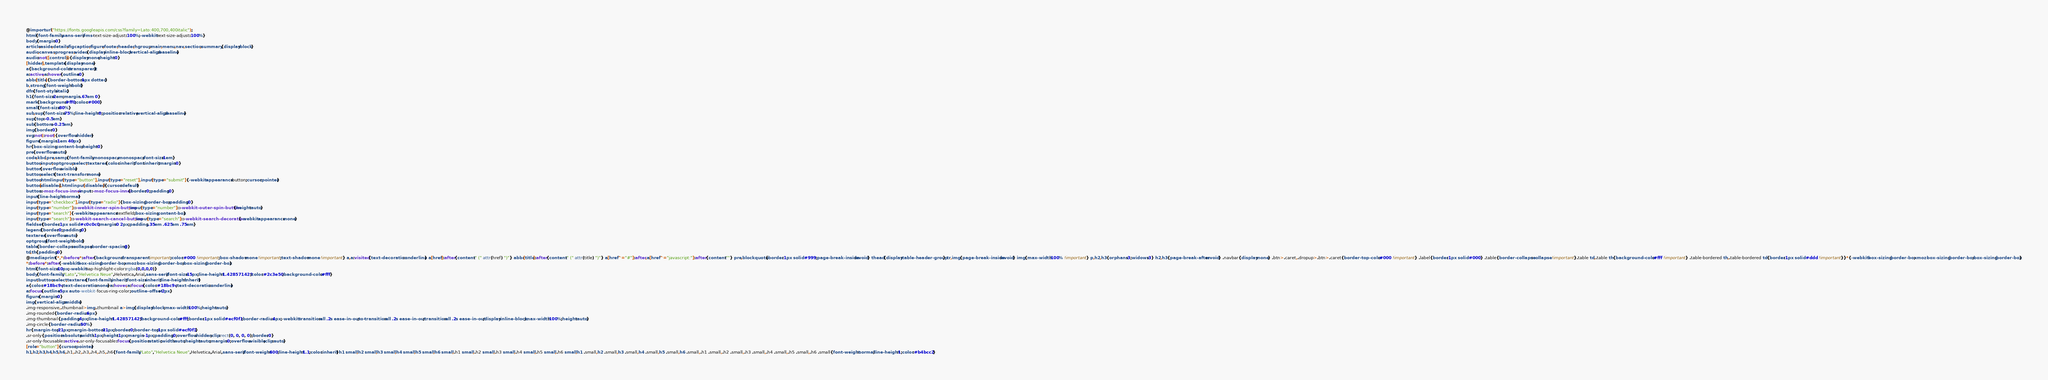Convert code to text. <code><loc_0><loc_0><loc_500><loc_500><_CSS_>@import url("https://fonts.googleapis.com/css?family=Lato:400,700,400italic");
html{font-family:sans-serif;-ms-text-size-adjust:100%;-webkit-text-size-adjust:100%}
body{margin:0}
article,aside,details,figcaption,figure,footer,header,hgroup,main,menu,nav,section,summary{display:block}
audio,canvas,progress,video{display:inline-block;vertical-align:baseline}
audio:not([controls]){display:none;height:0}
[hidden],template{display:none}
a{background-color:transparent}
a:active,a:hover{outline:0}
abbr[title]{border-bottom:1px dotted}
b,strong{font-weight:bold}
dfn{font-style:italic}
h1{font-size:2em;margin:.67em 0}
mark{background:#ff0;color:#000}
small{font-size:80%}
sub,sup{font-size:75%;line-height:0;position:relative;vertical-align:baseline}
sup{top:-0.5em}
sub{bottom:-0.25em}
img{border:0}
svg:not(:root){overflow:hidden}
figure{margin:1em 40px}
hr{box-sizing:content-box;height:0}
pre{overflow:auto}
code,kbd,pre,samp{font-family:monospace,monospace;font-size:1em}
button,input,optgroup,select,textarea{color:inherit;font:inherit;margin:0}
button{overflow:visible}
button,select{text-transform:none}
button,html input[type="button"],input[type="reset"],input[type="submit"]{-webkit-appearance:button;cursor:pointer}
button[disabled],html input[disabled]{cursor:default}
button::-moz-focus-inner,input::-moz-focus-inner{border:0;padding:0}
input{line-height:normal}
input[type="checkbox"],input[type="radio"]{box-sizing:border-box;padding:0}
input[type="number"]::-webkit-inner-spin-button,input[type="number"]::-webkit-outer-spin-button{height:auto}
input[type="search"]{-webkit-appearance:textfield;box-sizing:content-box}
input[type="search"]::-webkit-search-cancel-button,input[type="search"]::-webkit-search-decoration{-webkit-appearance:none}
fieldset{border:1px solid #c0c0c0;margin:0 2px;padding:.35em .625em .75em}
legend{border:0;padding:0}
textarea{overflow:auto}
optgroup{font-weight:bold}
table{border-collapse:collapse;border-spacing:0}
td,th{padding:0}
@media print{*,*:before,*:after{background:transparent !important;color:#000 !important;box-shadow:none !important;text-shadow:none !important} a,a:visited{text-decoration:underline} a[href]:after{content:" (" attr(href) ")"} abbr[title]:after{content:" (" attr(title) ")"} a[href^="#"]:after,a[href^="javascript:"]:after{content:""} pre,blockquote{border:1px solid #999;page-break-inside:avoid} thead{display:table-header-group} tr,img{page-break-inside:avoid} img{max-width:100% !important} p,h2,h3{orphans:3;widows:3} h2,h3{page-break-after:avoid} .navbar{display:none} .btn>.caret,.dropup>.btn>.caret{border-top-color:#000 !important} .label{border:1px solid #000} .table{border-collapse:collapse !important}.table td,.table th{background-color:#fff !important} .table-bordered th,.table-bordered td{border:1px solid #ddd !important}}*{-webkit-box-sizing:border-box;-moz-box-sizing:border-box;box-sizing:border-box}
*:before,*:after{-webkit-box-sizing:border-box;-moz-box-sizing:border-box;box-sizing:border-box}
html{font-size:10px;-webkit-tap-highlight-color:rgba(0,0,0,0)}
body{font-family:"Lato","Helvetica Neue",Helvetica,Arial,sans-serif;font-size:15px;line-height:1.428571429;color:#2c3e50;background-color:#fff}
input,button,select,textarea{font-family:inherit;font-size:inherit;line-height:inherit}
a{color:#18bc9c;text-decoration:none}a:hover,a:focus{color:#18bc9c;text-decoration:underline}
a:focus{outline:5px auto -webkit-focus-ring-color;outline-offset:-2px}
figure{margin:0}
img{vertical-align:middle}
.img-responsive,.thumbnail>img,.thumbnail a>img{display:block;max-width:100%;height:auto}
.img-rounded{border-radius:6px}
.img-thumbnail{padding:4px;line-height:1.428571429;background-color:#fff;border:1px solid #ecf0f1;border-radius:4px;-webkit-transition:all .2s ease-in-out;-o-transition:all .2s ease-in-out;transition:all .2s ease-in-out;display:inline-block;max-width:100%;height:auto}
.img-circle{border-radius:50%}
hr{margin-top:21px;margin-bottom:21px;border:0;border-top:1px solid #ecf0f1}
.sr-only{position:absolute;width:1px;height:1px;margin:-1px;padding:0;overflow:hidden;clip:rect(0, 0, 0, 0);border:0}
.sr-only-focusable:active,.sr-only-focusable:focus{position:static;width:auto;height:auto;margin:0;overflow:visible;clip:auto}
[role="button"]{cursor:pointer}
h1,h2,h3,h4,h5,h6,.h1,.h2,.h3,.h4,.h5,.h6{font-family:"Lato","Helvetica Neue",Helvetica,Arial,sans-serif;font-weight:400;line-height:1.1;color:inherit}h1 small,h2 small,h3 small,h4 small,h5 small,h6 small,.h1 small,.h2 small,.h3 small,.h4 small,.h5 small,.h6 small,h1 .small,h2 .small,h3 .small,h4 .small,h5 .small,h6 .small,.h1 .small,.h2 .small,.h3 .small,.h4 .small,.h5 .small,.h6 .small{font-weight:normal;line-height:1;color:#b4bcc2}</code> 